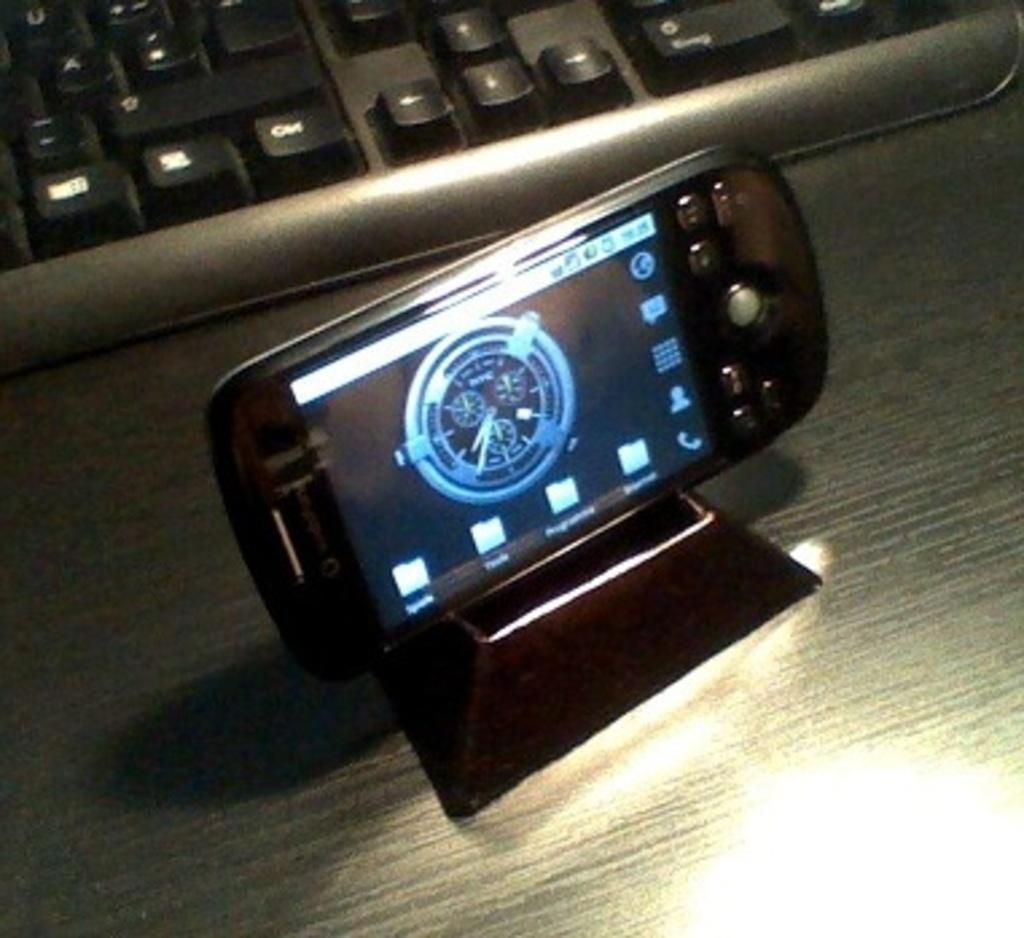What is the main object on the stand in the image? There is a mobile on a stand in the image. What is the main object on the table in the image? There is a keyboard on a table in the image. What type of wire is used to connect the keyboard to the mobile in the image? There is no wire connecting the keyboard to the mobile in the image. The keyboard and mobile are separate objects in the image. How does the friction between the mobile and the stand affect the stability of the mobile in the image? There is no mention of friction or stability in the image. The mobile is simply placed on the stand. 